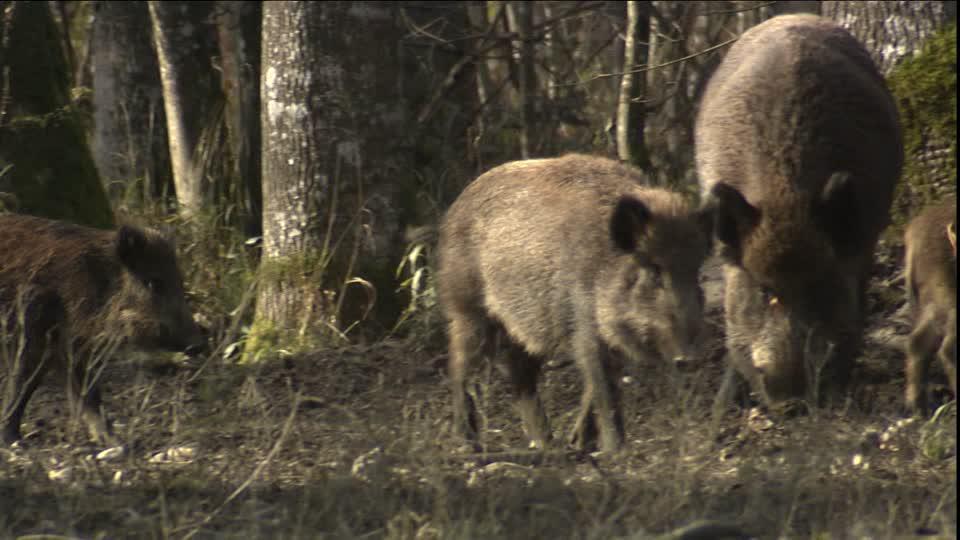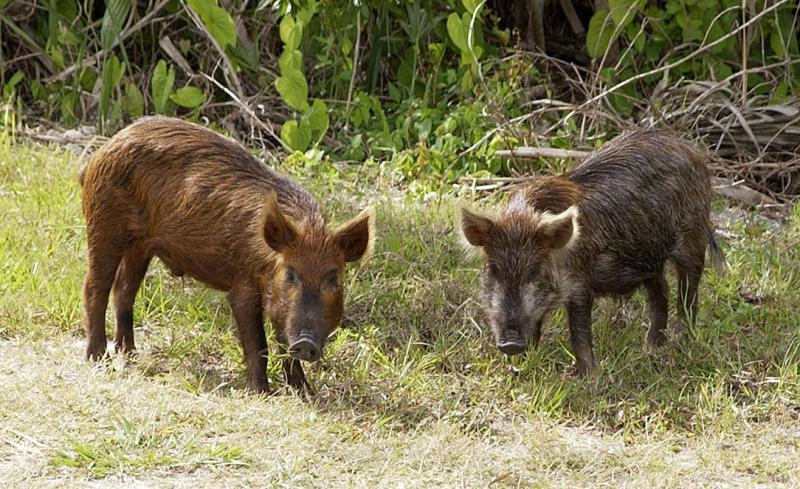The first image is the image on the left, the second image is the image on the right. Considering the images on both sides, is "There are multiple wild boars in the center of both images." valid? Answer yes or no. Yes. The first image is the image on the left, the second image is the image on the right. For the images shown, is this caption "Contains one picture with three or less pigs." true? Answer yes or no. Yes. 